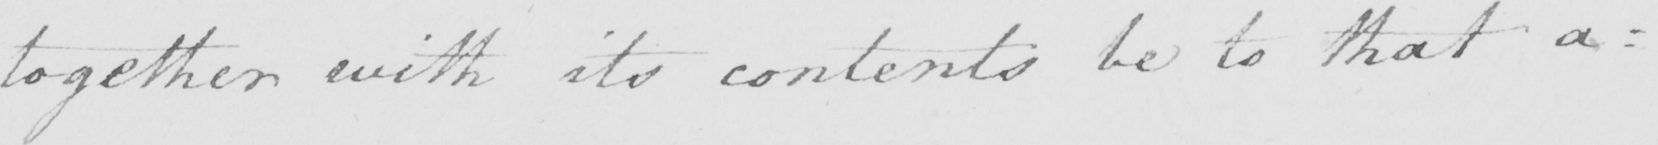What is written in this line of handwriting? together with its contents be to that a : 